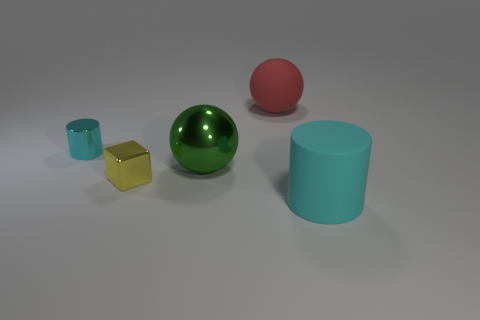Add 1 small yellow cylinders. How many objects exist? 6 Subtract all balls. How many objects are left? 3 Subtract 0 blue cylinders. How many objects are left? 5 Subtract all big balls. Subtract all big red spheres. How many objects are left? 2 Add 5 metallic cubes. How many metallic cubes are left? 6 Add 4 cyan metallic cylinders. How many cyan metallic cylinders exist? 5 